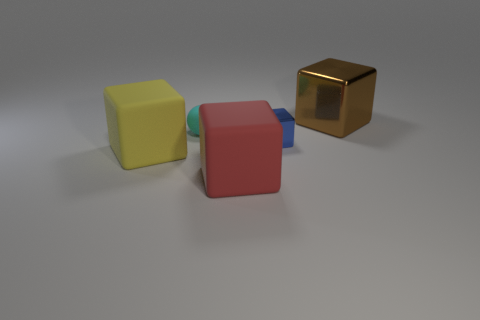Add 5 large yellow matte cubes. How many objects exist? 10 Subtract all blocks. How many objects are left? 1 Subtract all cyan cylinders. Subtract all yellow things. How many objects are left? 4 Add 5 blue objects. How many blue objects are left? 6 Add 5 small cylinders. How many small cylinders exist? 5 Subtract 1 yellow blocks. How many objects are left? 4 